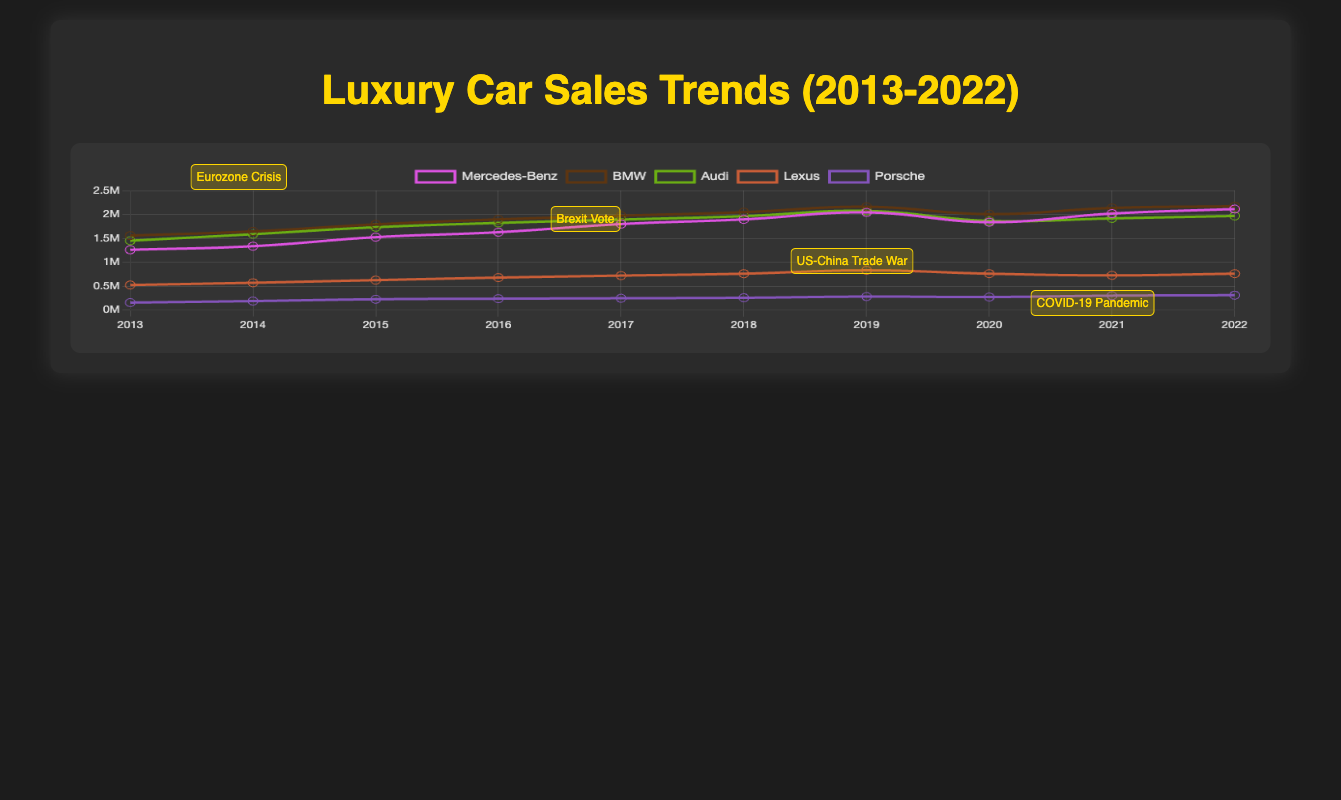What's the highest sales figure for Mercedes-Benz? By looking at the Mercedes-Benz sales line, the highest point is in 2022 with a value of 2,113,000.
Answer: 2,113,000 How did BMW sales change from 2019 to 2020? The BMW sales figure in 2019 is 2,160,000, whereas in 2020 it is 2,006,000. The change is 2,006,000 - 2,160,000 = -154,000.
Answer: -154,000 Which brand had the least sales in 2020, and what was the figure? By comparing the sales for all brands in 2020, Lexus had the lowest sales figure with 760,000 units.
Answer: Lexus with 760,000 units What's the average sales figure for Audi from 2013 to 2022? Sum the sales figures for Audi from 2013 to 2022 and divide by the number of years. The sum is 1,450,000 + 1,586,000 + 1,732,000 + 1,822,000 + 1,892,000 + 1,964,000 + 2,074,000 + 1,864,000 + 1,917,000 + 1,968,000 = 18,269,000. Divide by 10 (number of years): 18,269,000 / 10 = 1,826,900.
Answer: 1,826,900 In which year did Porsche see the most significant increase in sales compared to the previous year? To find this, look for the biggest difference between the sales of consecutive years. The differences are: 2014-2013: 187,000 - 155,000 = 32,000; 2015-2014: 225,000 - 187,000 = 38,000; 2016-2015: 237,000 - 225,000 = 12,000; 2017-2016: 246,000 - 237,000 = 9,000; 2018-2017: 256,000 - 246,000 = 10,000; 2019-2018: 281,000 - 256,000 = 25,000; 2020-2019: 272,000 - 281,000 = -9,000; 2021-2020: 300,000 - 272,000 = 28,000; 2022-2021: 309,900 - 300,000 = 9,900. The biggest increase is from 2014 to 2015 with 38,000.
Answer: 2015 with 38,000 Did any brand show a continuous increase in sales every single year? By examining each brand's sales trends, no brand shows a continuous increase every single year without at least one decrease.
Answer: No How did the COVID-19 pandemic in 2020 affect the sales of Lexus? Lexus sales in 2019 were 830,000 and dropped to 760,000 in 2020 due to the COVID-19 pandemic. The change is 760,000 - 830,000 = -70,000.
Answer: -70,000 Which brand rebounded the most in sales after the COVID-19 pandemic in 2021? By comparing 2020 to 2021 sales figures: Mercedes-Benz: 2,018,000 - 1,837,000 = 181,000; BMW: 2,135,000 - 2,006,000 = 129,000; Audi: 1,917,000 - 1,864,000 = 53,000; Lexus: 725,000 - 760,000 = -35,000 (no rebound); Porsche: 300,000 - 272,000 = 28,000. The highest rebound is seen in Mercedes-Benz with 181,000 units.
Answer: Mercedes-Benz with 181,000 units 